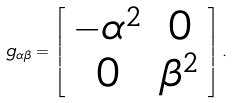<formula> <loc_0><loc_0><loc_500><loc_500>g _ { \alpha \beta } = \left [ \begin{array} { c c } - \alpha ^ { 2 } & 0 \\ 0 & \beta ^ { 2 } \end{array} \right ] .</formula> 